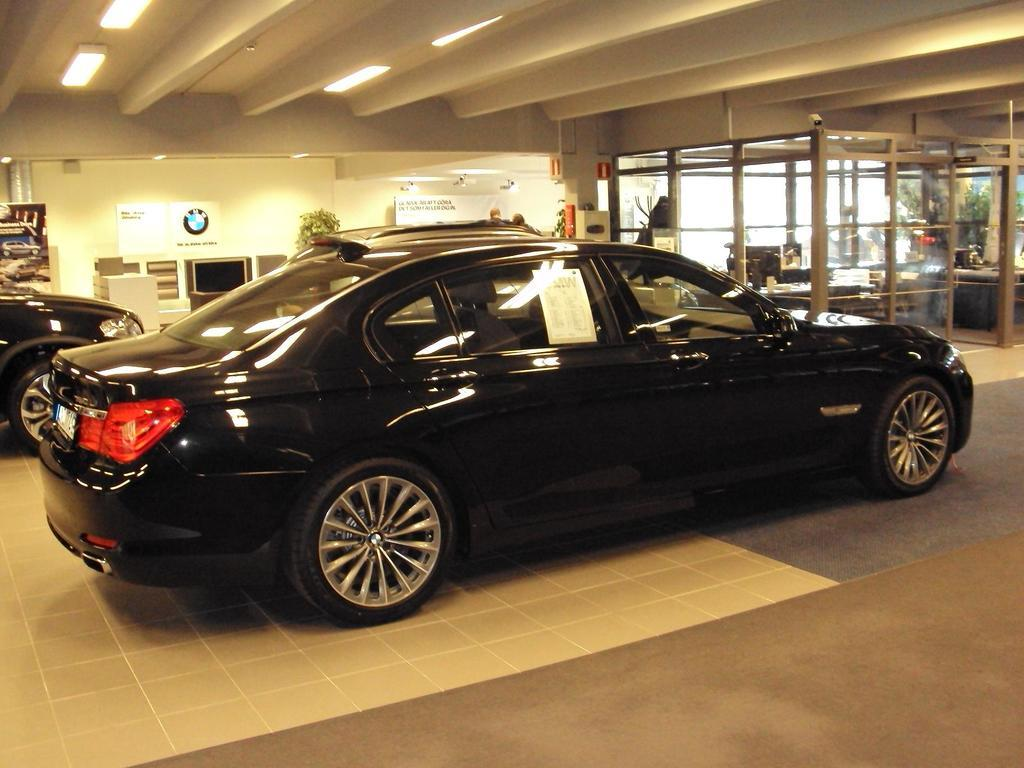What is the main subject of the image? The main subject of the image is cars. What can be seen in the background of the image? In the background of the image, there are trees, lights, and posters on a wall. What type of writer is sitting on the hood of the car in the image? There is no writer present in the image, and no one is sitting on the hood of the car. 